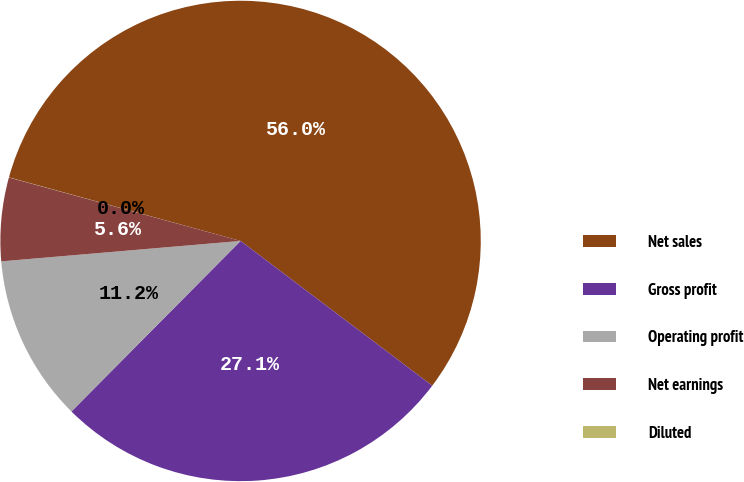<chart> <loc_0><loc_0><loc_500><loc_500><pie_chart><fcel>Net sales<fcel>Gross profit<fcel>Operating profit<fcel>Net earnings<fcel>Diluted<nl><fcel>56.03%<fcel>27.14%<fcel>11.21%<fcel>5.61%<fcel>0.01%<nl></chart> 